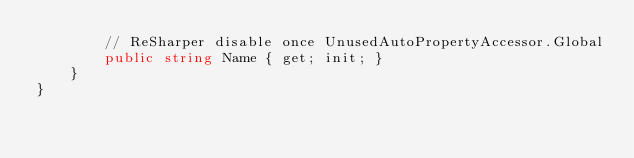<code> <loc_0><loc_0><loc_500><loc_500><_C#_>        // ReSharper disable once UnusedAutoPropertyAccessor.Global
        public string Name { get; init; }
    }
}
</code> 